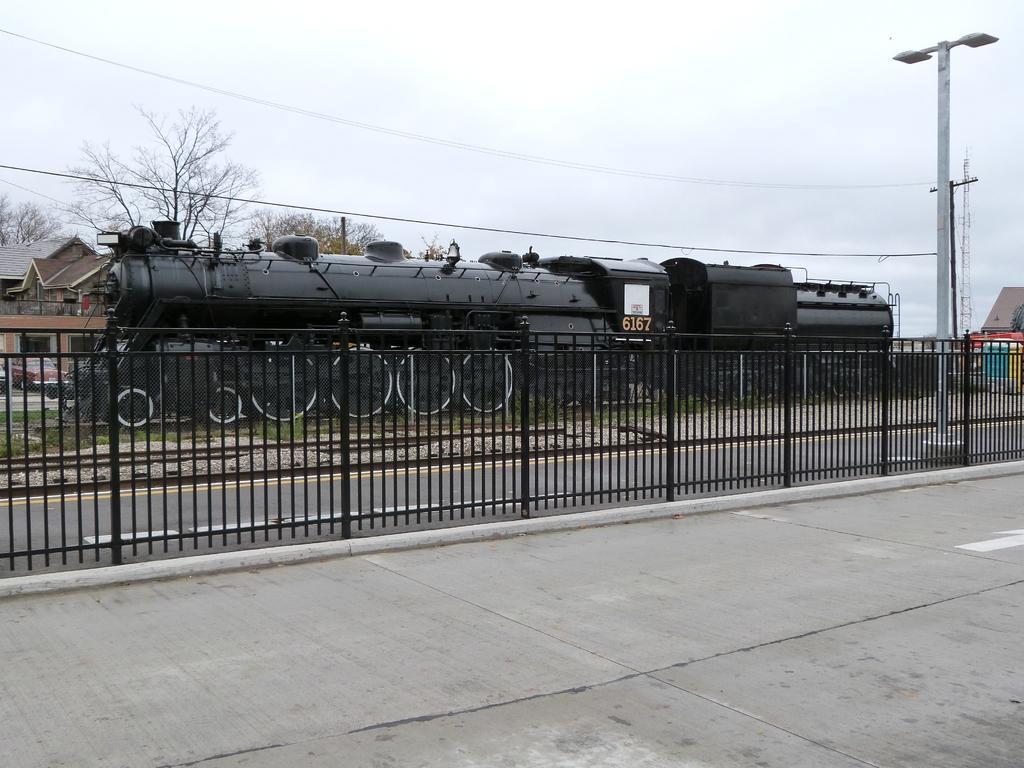Can you describe this image briefly? In this image at the bottom we can see cement road at the fence and to the other side of the fence we can see lights on a pole, road and objects. In the background there is a train on the railway track, trees, pole, electric wires, houses, windows, vehicles on the road, tower and clouds in the sky. 